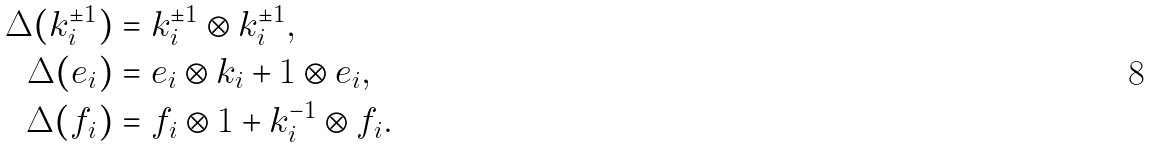<formula> <loc_0><loc_0><loc_500><loc_500>\Delta ( k _ { i } ^ { \pm 1 } ) & = k _ { i } ^ { \pm 1 } \otimes k _ { i } ^ { \pm 1 } , \\ \Delta ( e _ { i } ) & = e _ { i } \otimes k _ { i } + 1 \otimes e _ { i } , \\ \Delta ( f _ { i } ) & = f _ { i } \otimes 1 + k _ { i } ^ { - 1 } \otimes f _ { i } .</formula> 